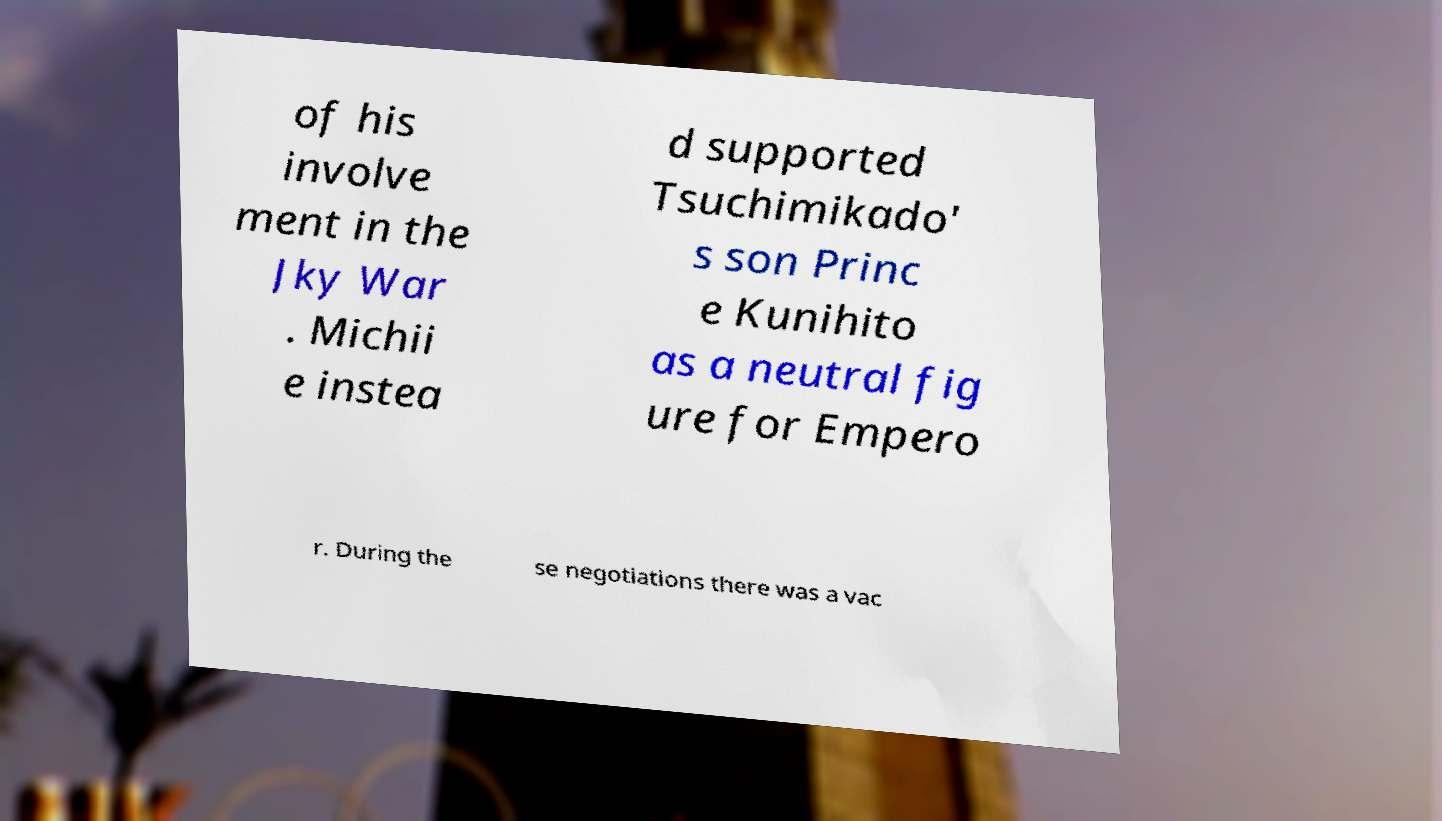For documentation purposes, I need the text within this image transcribed. Could you provide that? of his involve ment in the Jky War . Michii e instea d supported Tsuchimikado' s son Princ e Kunihito as a neutral fig ure for Empero r. During the se negotiations there was a vac 